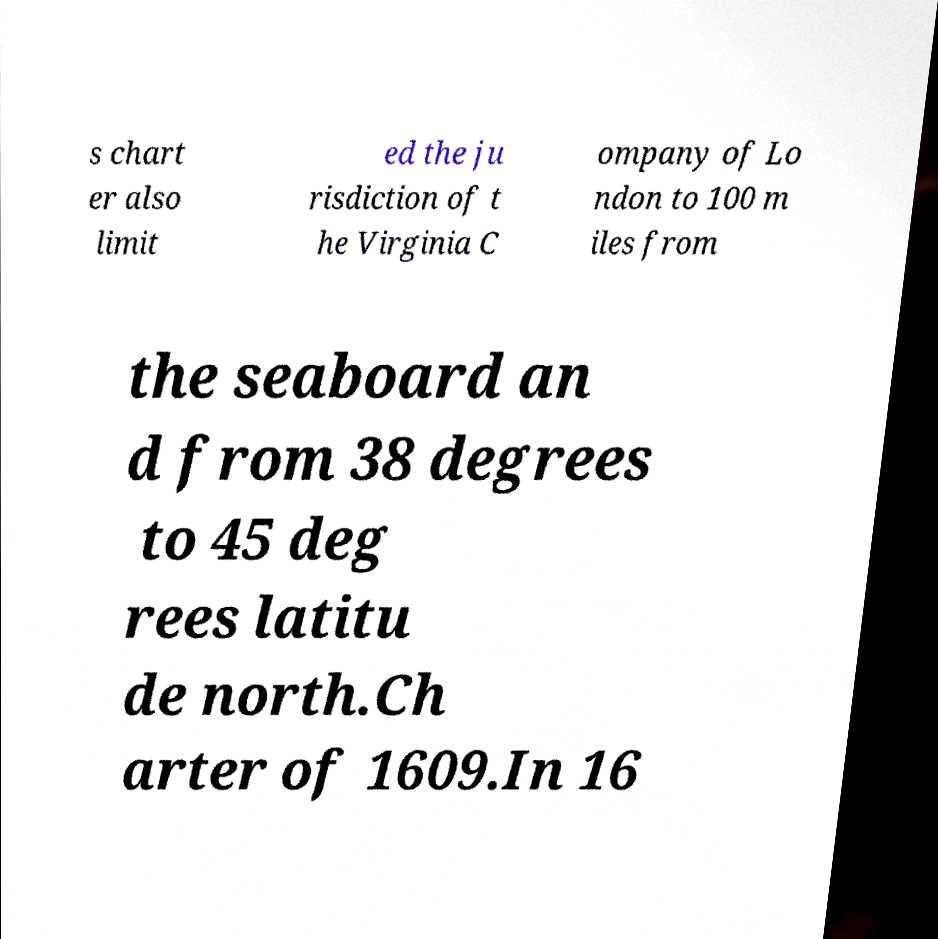There's text embedded in this image that I need extracted. Can you transcribe it verbatim? s chart er also limit ed the ju risdiction of t he Virginia C ompany of Lo ndon to 100 m iles from the seaboard an d from 38 degrees to 45 deg rees latitu de north.Ch arter of 1609.In 16 